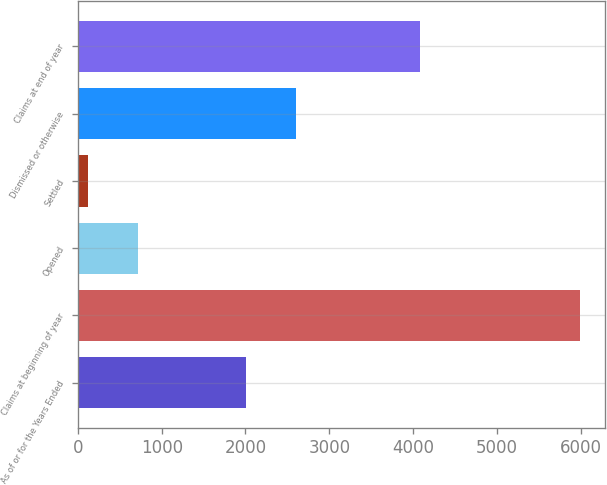Convert chart to OTSL. <chart><loc_0><loc_0><loc_500><loc_500><bar_chart><fcel>As of or for the Years Ended<fcel>Claims at beginning of year<fcel>Opened<fcel>Settled<fcel>Dismissed or otherwise<fcel>Claims at end of year<nl><fcel>2010<fcel>5994<fcel>711.9<fcel>125<fcel>2596.9<fcel>4087<nl></chart> 